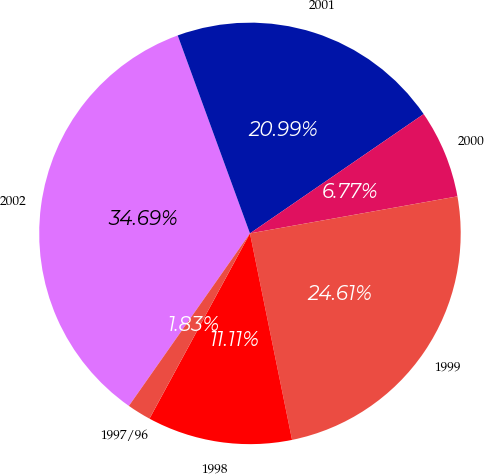Convert chart to OTSL. <chart><loc_0><loc_0><loc_500><loc_500><pie_chart><fcel>2002<fcel>2001<fcel>2000<fcel>1999<fcel>1998<fcel>1997/96<nl><fcel>34.69%<fcel>20.99%<fcel>6.77%<fcel>24.61%<fcel>11.11%<fcel>1.83%<nl></chart> 